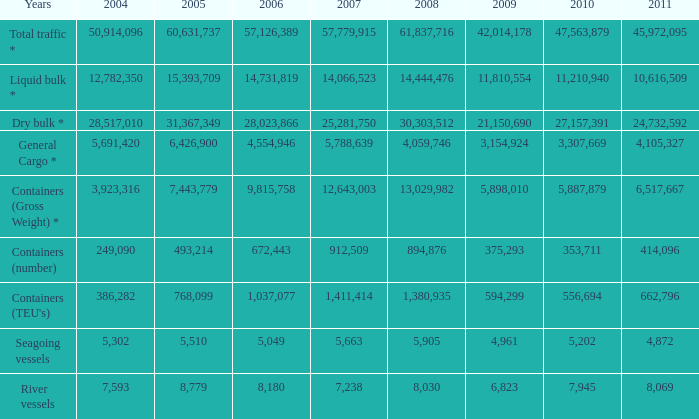Taking into account that there were over 8,030 river vessels in 2008 and more than 1,411,414 in 2007, what was the total count of their years 0.0. 